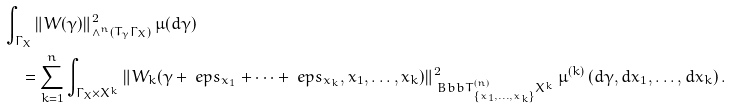<formula> <loc_0><loc_0><loc_500><loc_500>& \int _ { \Gamma _ { X } } \| W ( \gamma ) \| ^ { 2 } _ { \wedge ^ { n } ( T _ { \gamma } \Gamma _ { X } ) } \, \mu ( d \gamma ) \\ & \quad = \sum _ { k = 1 } ^ { n } \int _ { \Gamma _ { X } \times X ^ { k } } \| W _ { k } ( \gamma + \ e p s _ { x _ { 1 } } + \dots + \ e p s _ { x _ { k } } , x _ { 1 } , \dots , x _ { k } ) \| ^ { 2 } _ { { \ B b b T } _ { \left \{ x _ { 1 } , \dots , x _ { k } \right \} } ^ { ( n ) } X ^ { k } } \, \mu ^ { ( k ) } \left ( d \gamma , d x _ { 1 } , \dots , d x _ { k } \right ) .</formula> 